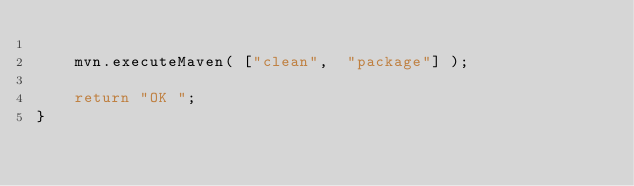Convert code to text. <code><loc_0><loc_0><loc_500><loc_500><_JavaScript_>
    mvn.executeMaven( ["clean",  "package"] );

    return "OK ";
}
</code> 